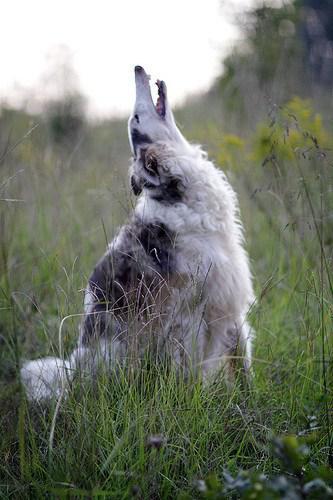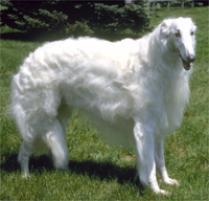The first image is the image on the left, the second image is the image on the right. Examine the images to the left and right. Is the description "There are two dogs total, facing both left and right." accurate? Answer yes or no. No. The first image is the image on the left, the second image is the image on the right. Analyze the images presented: Is the assertion "One dog is facing left and one dog is facing right." valid? Answer yes or no. No. 